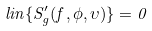Convert formula to latex. <formula><loc_0><loc_0><loc_500><loc_500>l i n \{ S ^ { \prime } _ { g } ( f , \phi , \upsilon ) \} = 0</formula> 